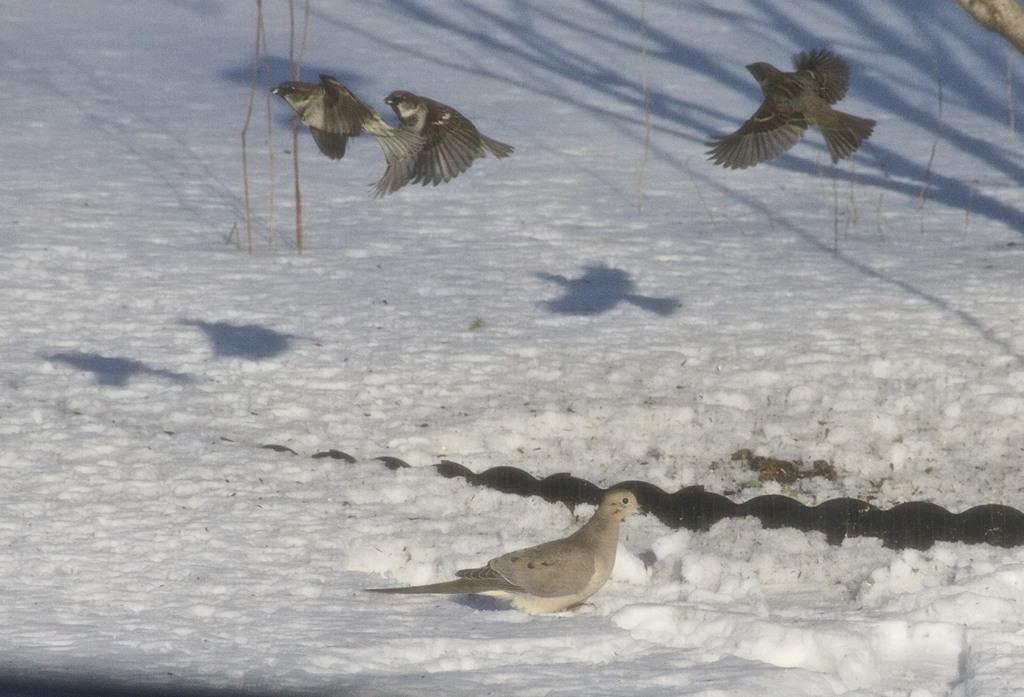Describe this image in one or two sentences. In the image on the ground there is snow and there is a bird standing on the snow. There are three birds flying in the air. 